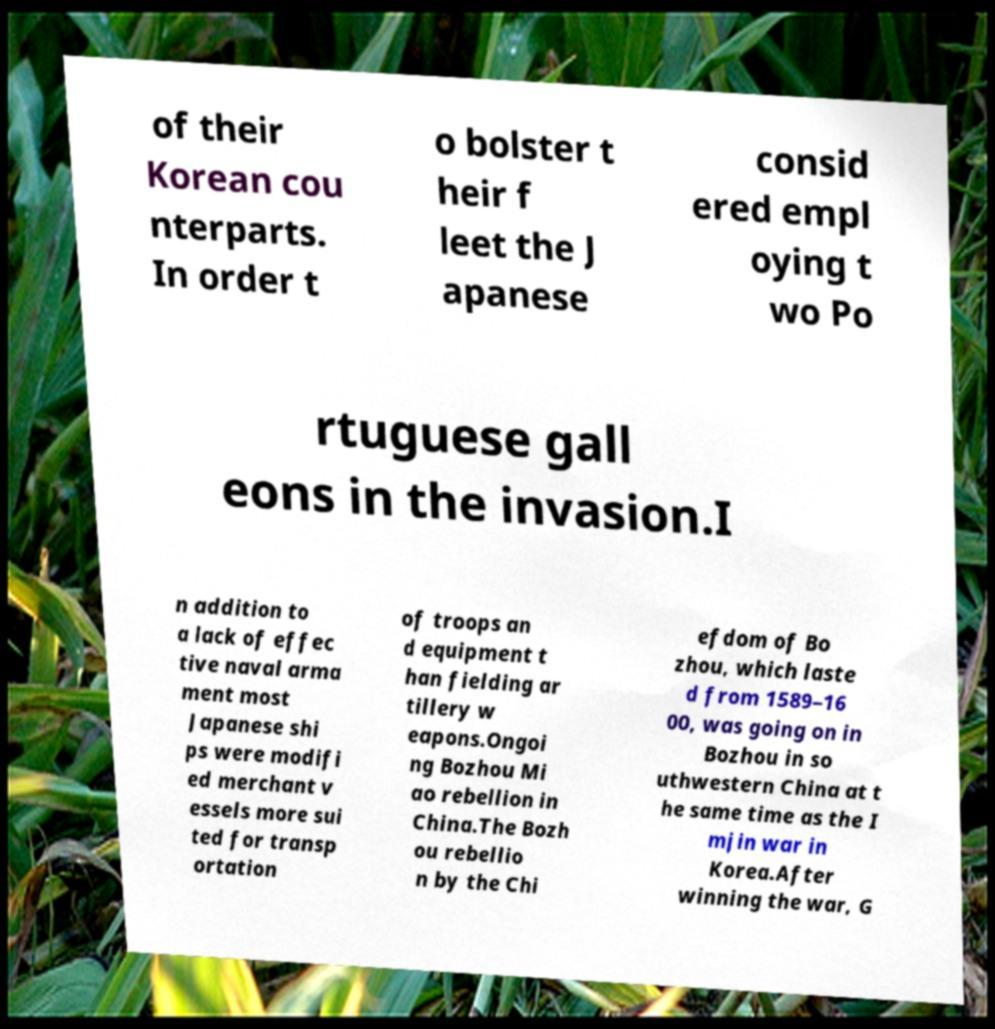Please identify and transcribe the text found in this image. of their Korean cou nterparts. In order t o bolster t heir f leet the J apanese consid ered empl oying t wo Po rtuguese gall eons in the invasion.I n addition to a lack of effec tive naval arma ment most Japanese shi ps were modifi ed merchant v essels more sui ted for transp ortation of troops an d equipment t han fielding ar tillery w eapons.Ongoi ng Bozhou Mi ao rebellion in China.The Bozh ou rebellio n by the Chi efdom of Bo zhou, which laste d from 1589–16 00, was going on in Bozhou in so uthwestern China at t he same time as the I mjin war in Korea.After winning the war, G 